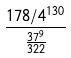Convert formula to latex. <formula><loc_0><loc_0><loc_500><loc_500>\frac { 1 7 8 / 4 ^ { 1 3 0 } } { \frac { 3 7 ^ { 9 } } { 3 2 2 } }</formula> 